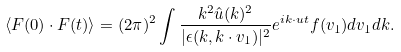<formula> <loc_0><loc_0><loc_500><loc_500>\langle { F } ( 0 ) \cdot { F } ( t ) \rangle = ( 2 \pi ) ^ { 2 } \int \frac { k ^ { 2 } \hat { u } ( k ) ^ { 2 } } { | \epsilon ( { k } , { k } \cdot { v } _ { 1 } ) | ^ { 2 } } e ^ { i { k } \cdot { u } t } f ( { v } _ { 1 } ) d { v } _ { 1 } d { k } .</formula> 